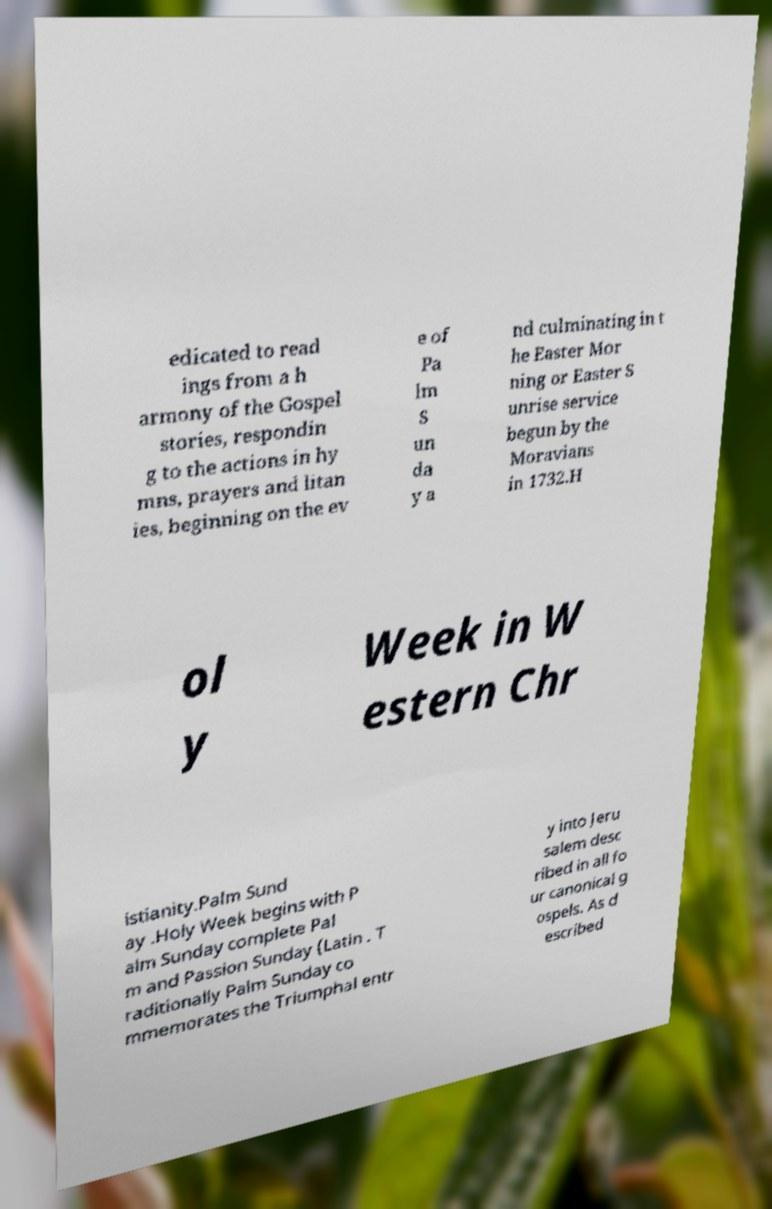Please identify and transcribe the text found in this image. edicated to read ings from a h armony of the Gospel stories, respondin g to the actions in hy mns, prayers and litan ies, beginning on the ev e of Pa lm S un da y a nd culminating in t he Easter Mor ning or Easter S unrise service begun by the Moravians in 1732.H ol y Week in W estern Chr istianity.Palm Sund ay .Holy Week begins with P alm Sunday complete Pal m and Passion Sunday (Latin . T raditionally Palm Sunday co mmemorates the Triumphal entr y into Jeru salem desc ribed in all fo ur canonical g ospels. As d escribed 